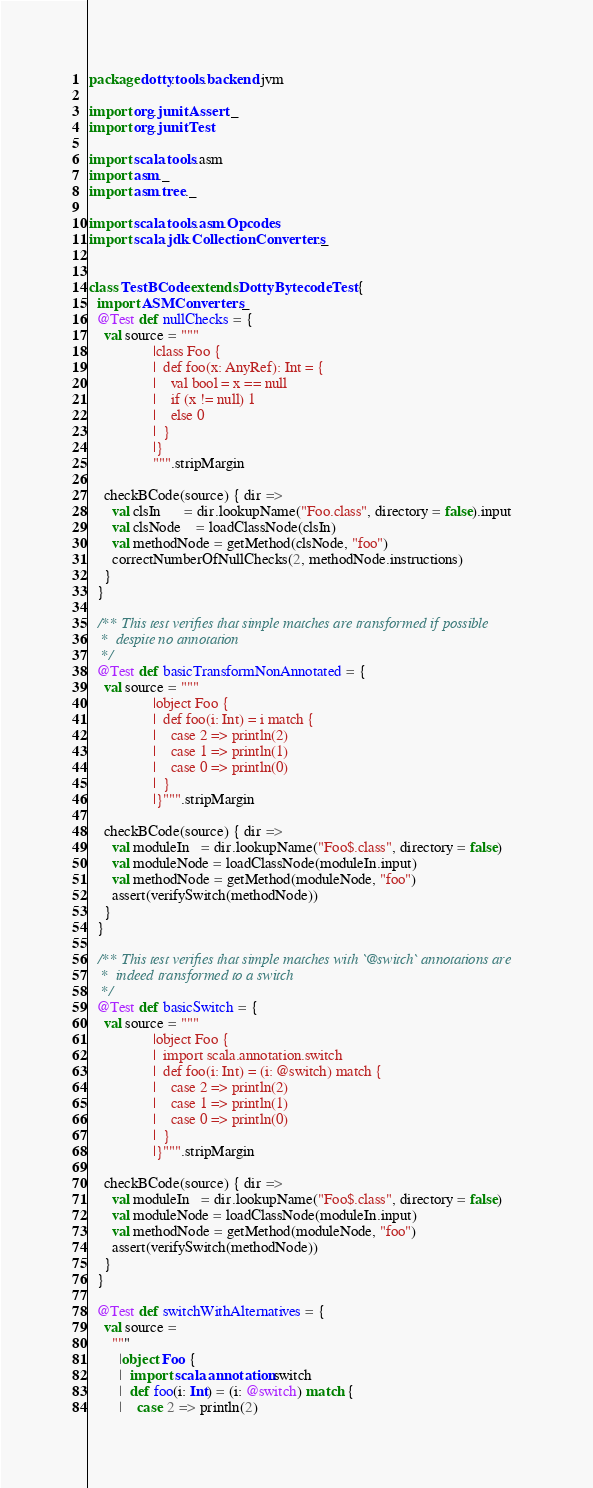<code> <loc_0><loc_0><loc_500><loc_500><_Scala_>package dotty.tools.backend.jvm

import org.junit.Assert._
import org.junit.Test

import scala.tools.asm
import asm._
import asm.tree._

import scala.tools.asm.Opcodes
import scala.jdk.CollectionConverters._


class TestBCode extends DottyBytecodeTest {
  import ASMConverters._
  @Test def nullChecks = {
    val source = """
                 |class Foo {
                 |  def foo(x: AnyRef): Int = {
                 |    val bool = x == null
                 |    if (x != null) 1
                 |    else 0
                 |  }
                 |}
                 """.stripMargin

    checkBCode(source) { dir =>
      val clsIn      = dir.lookupName("Foo.class", directory = false).input
      val clsNode    = loadClassNode(clsIn)
      val methodNode = getMethod(clsNode, "foo")
      correctNumberOfNullChecks(2, methodNode.instructions)
    }
  }

  /** This test verifies that simple matches are transformed if possible
   *  despite no annotation
   */
  @Test def basicTransformNonAnnotated = {
    val source = """
                 |object Foo {
                 |  def foo(i: Int) = i match {
                 |    case 2 => println(2)
                 |    case 1 => println(1)
                 |    case 0 => println(0)
                 |  }
                 |}""".stripMargin

    checkBCode(source) { dir =>
      val moduleIn   = dir.lookupName("Foo$.class", directory = false)
      val moduleNode = loadClassNode(moduleIn.input)
      val methodNode = getMethod(moduleNode, "foo")
      assert(verifySwitch(methodNode))
    }
  }

  /** This test verifies that simple matches with `@switch` annotations are
   *  indeed transformed to a switch
   */
  @Test def basicSwitch = {
    val source = """
                 |object Foo {
                 |  import scala.annotation.switch
                 |  def foo(i: Int) = (i: @switch) match {
                 |    case 2 => println(2)
                 |    case 1 => println(1)
                 |    case 0 => println(0)
                 |  }
                 |}""".stripMargin

    checkBCode(source) { dir =>
      val moduleIn   = dir.lookupName("Foo$.class", directory = false)
      val moduleNode = loadClassNode(moduleIn.input)
      val methodNode = getMethod(moduleNode, "foo")
      assert(verifySwitch(methodNode))
    }
  }

  @Test def switchWithAlternatives = {
    val source =
      """
        |object Foo {
        |  import scala.annotation.switch
        |  def foo(i: Int) = (i: @switch) match {
        |    case 2 => println(2)</code> 